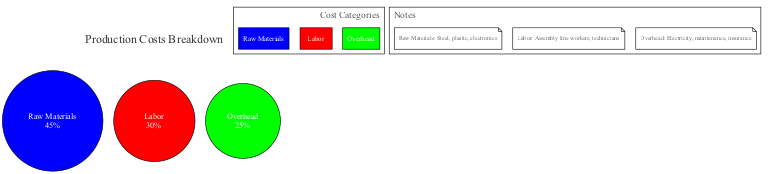what percentage of production costs is attributed to labor? The diagram provides specific percentages for each segment of production costs. The segment labeled "Labor" shows a percentage of 30, which indicates the part of the total costs that labor represents.
Answer: 30 how many segments are there in the pie chart? By examining the diagram, we can count the different sections categorized. There are three segments: Raw Materials, Labor, and Overhead, indicating the categorized breakdown of production costs.
Answer: 3 what segment has the highest percentage of costs? In the pie chart, we compare the percentages of each segment. Raw Materials with 45% is greater than both Labor at 30% and Overhead at 25%, making it the highest segment.
Answer: Raw Materials what color represents overhead costs? Looking at the diagram, each segment is represented by a specific color. Overhead is labeled with the color green, indicating its visual representation in the pie chart.
Answer: green which category has the least percentage of costs? By comparing the percentages indicated in the segments, we see that Overhead at 25% is lower than both Raw Materials at 45% and Labor at 30%. Thus, Overhead has the least percentage of production costs.
Answer: Overhead what are the components included in raw materials? The notes accompanying the diagram specify the components of each cost category. For Raw Materials, the notes mention steel, plastic, and electronics.
Answer: steel, plastic, electronics what is the total percentage shown in the pie chart? In a pie chart, the total of all segments should add up to 100%. We can confirm by adding the individual percentages: 45% + 30% + 25% = 100%.
Answer: 100 how is the legend positioned in the diagram? The legend is specifically mentioned in the data section of the diagram information, stating that it is located on the right side. Therefore, we find the legend positioned right next to the pie chart.
Answer: right what type of diagram is presented? The provided information explicitly mentions that the chart is a "Pie Chart," which defines the structure and representation method of the data.
Answer: Pie Chart 